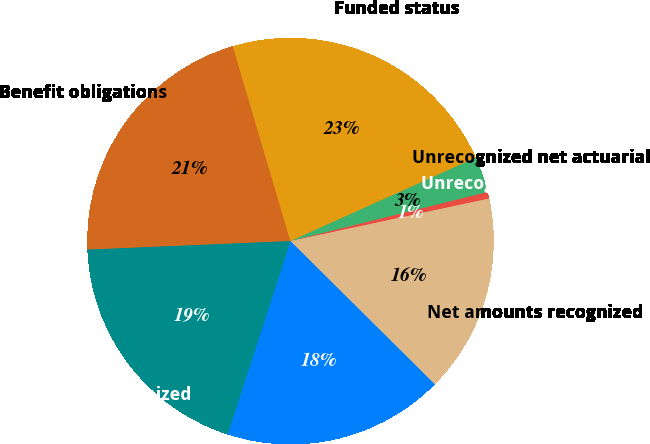Convert chart. <chart><loc_0><loc_0><loc_500><loc_500><pie_chart><fcel>Benefit obligations<fcel>Funded status<fcel>Unrecognized net actuarial<fcel>Unrecognized prior service<fcel>Net amounts recognized<fcel>Accrued benefit cost<fcel>Net amount recognized<nl><fcel>21.09%<fcel>22.85%<fcel>2.85%<fcel>0.52%<fcel>15.8%<fcel>17.56%<fcel>19.33%<nl></chart> 